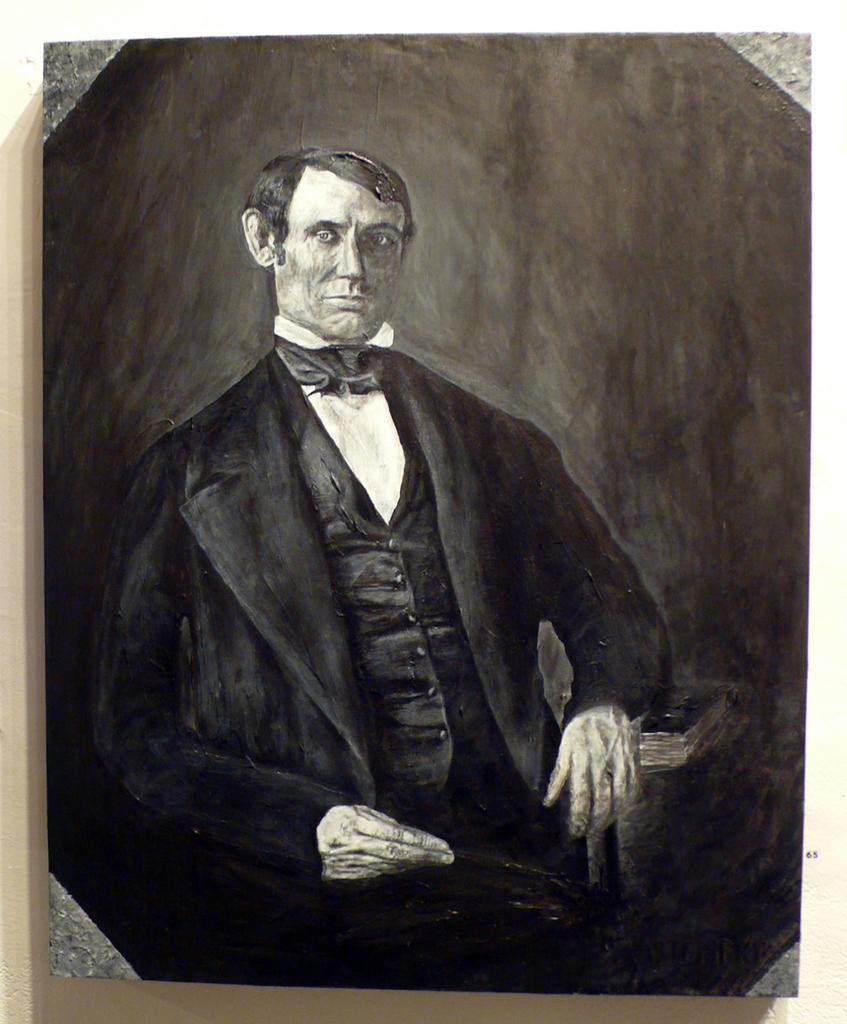Could you give a brief overview of what you see in this image? In this image there is a depiction of a person. Behind him there is a wall. 